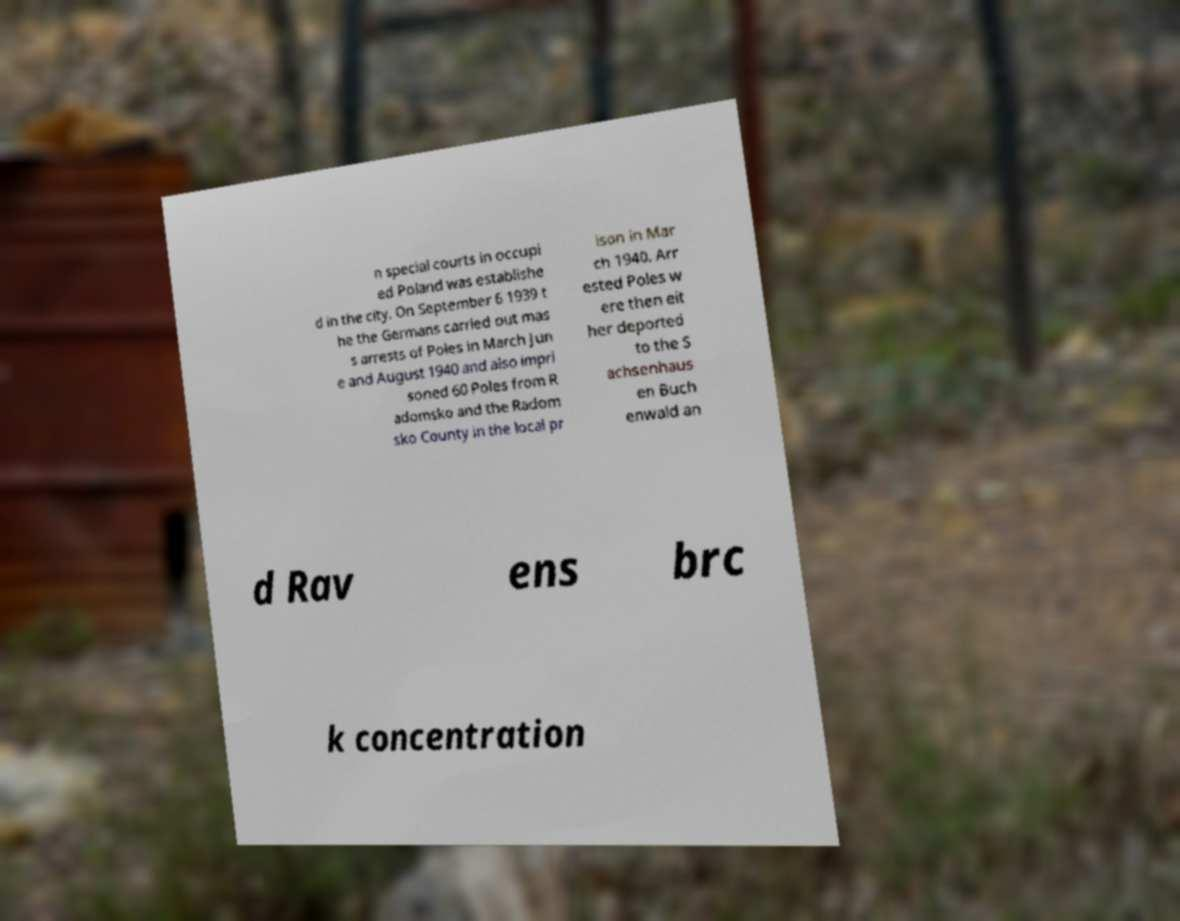There's text embedded in this image that I need extracted. Can you transcribe it verbatim? n special courts in occupi ed Poland was establishe d in the city. On September 6 1939 t he the Germans carried out mas s arrests of Poles in March Jun e and August 1940 and also impri soned 60 Poles from R adomsko and the Radom sko County in the local pr ison in Mar ch 1940. Arr ested Poles w ere then eit her deported to the S achsenhaus en Buch enwald an d Rav ens brc k concentration 